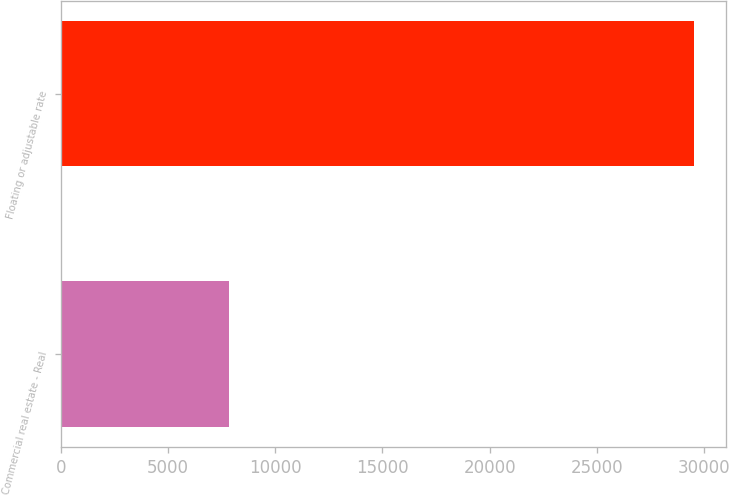<chart> <loc_0><loc_0><loc_500><loc_500><bar_chart><fcel>Commercial real estate - Real<fcel>Floating or adjustable rate<nl><fcel>7868<fcel>29537<nl></chart> 